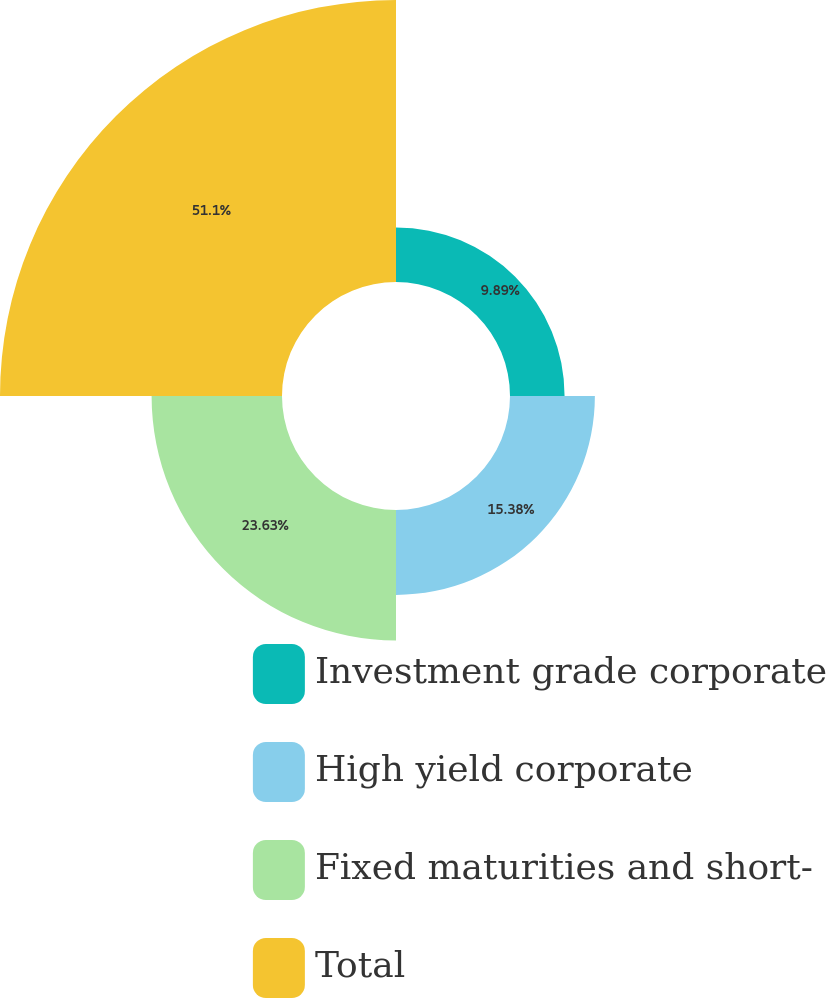<chart> <loc_0><loc_0><loc_500><loc_500><pie_chart><fcel>Investment grade corporate<fcel>High yield corporate<fcel>Fixed maturities and short-<fcel>Total<nl><fcel>9.89%<fcel>15.38%<fcel>23.63%<fcel>51.1%<nl></chart> 